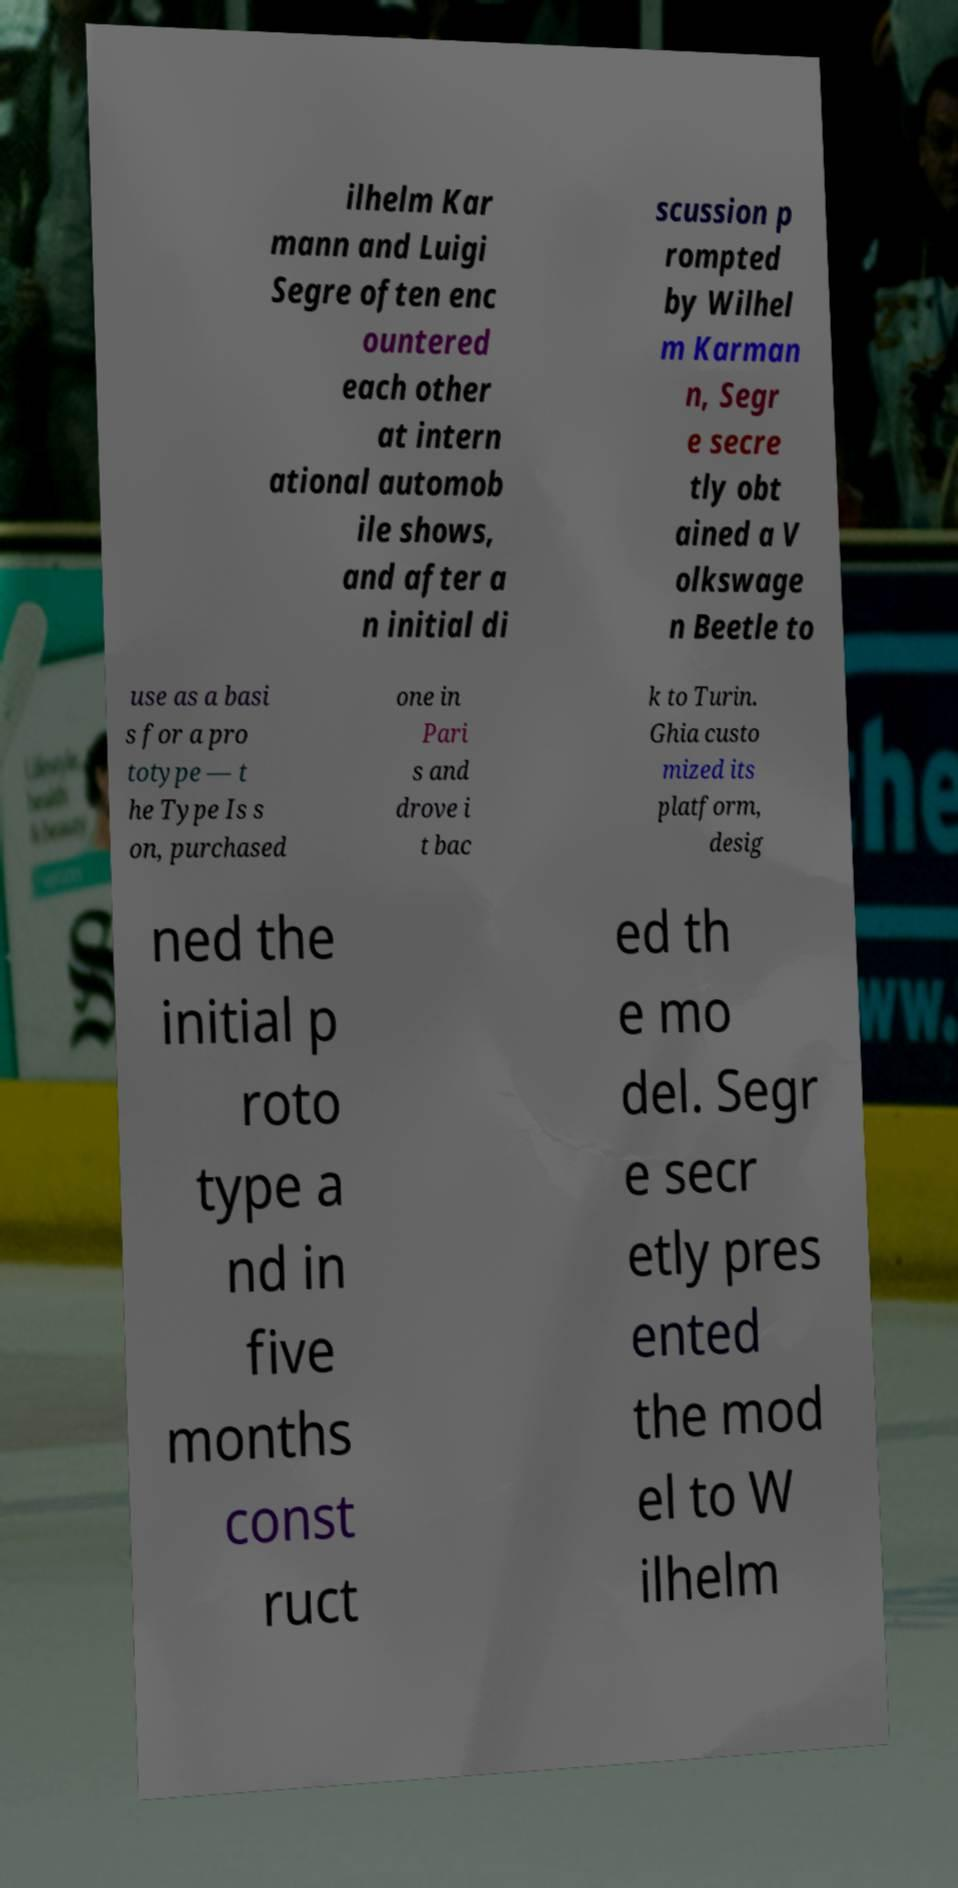Please read and relay the text visible in this image. What does it say? ilhelm Kar mann and Luigi Segre often enc ountered each other at intern ational automob ile shows, and after a n initial di scussion p rompted by Wilhel m Karman n, Segr e secre tly obt ained a V olkswage n Beetle to use as a basi s for a pro totype — t he Type Is s on, purchased one in Pari s and drove i t bac k to Turin. Ghia custo mized its platform, desig ned the initial p roto type a nd in five months const ruct ed th e mo del. Segr e secr etly pres ented the mod el to W ilhelm 